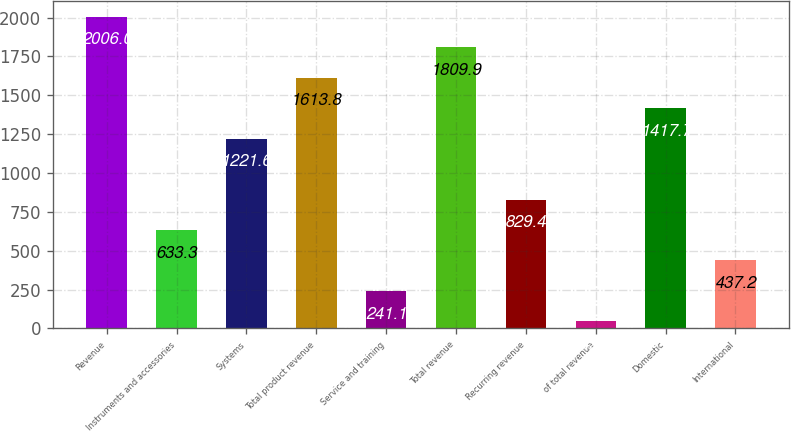<chart> <loc_0><loc_0><loc_500><loc_500><bar_chart><fcel>Revenue<fcel>Instruments and accessories<fcel>Systems<fcel>Total product revenue<fcel>Service and training<fcel>Total revenue<fcel>Recurring revenue<fcel>of total revenue<fcel>Domestic<fcel>International<nl><fcel>2006<fcel>633.3<fcel>1221.6<fcel>1613.8<fcel>241.1<fcel>1809.9<fcel>829.4<fcel>45<fcel>1417.7<fcel>437.2<nl></chart> 